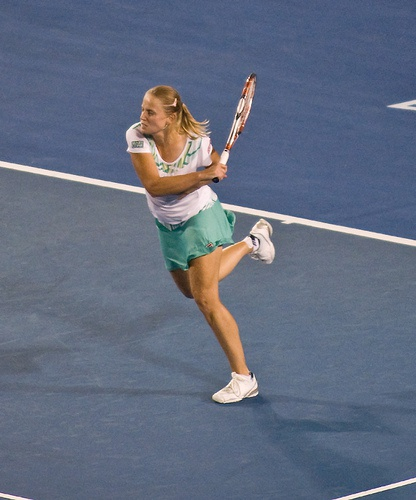Describe the objects in this image and their specific colors. I can see people in gray, tan, lightgray, brown, and darkgray tones and tennis racket in gray, white, and tan tones in this image. 